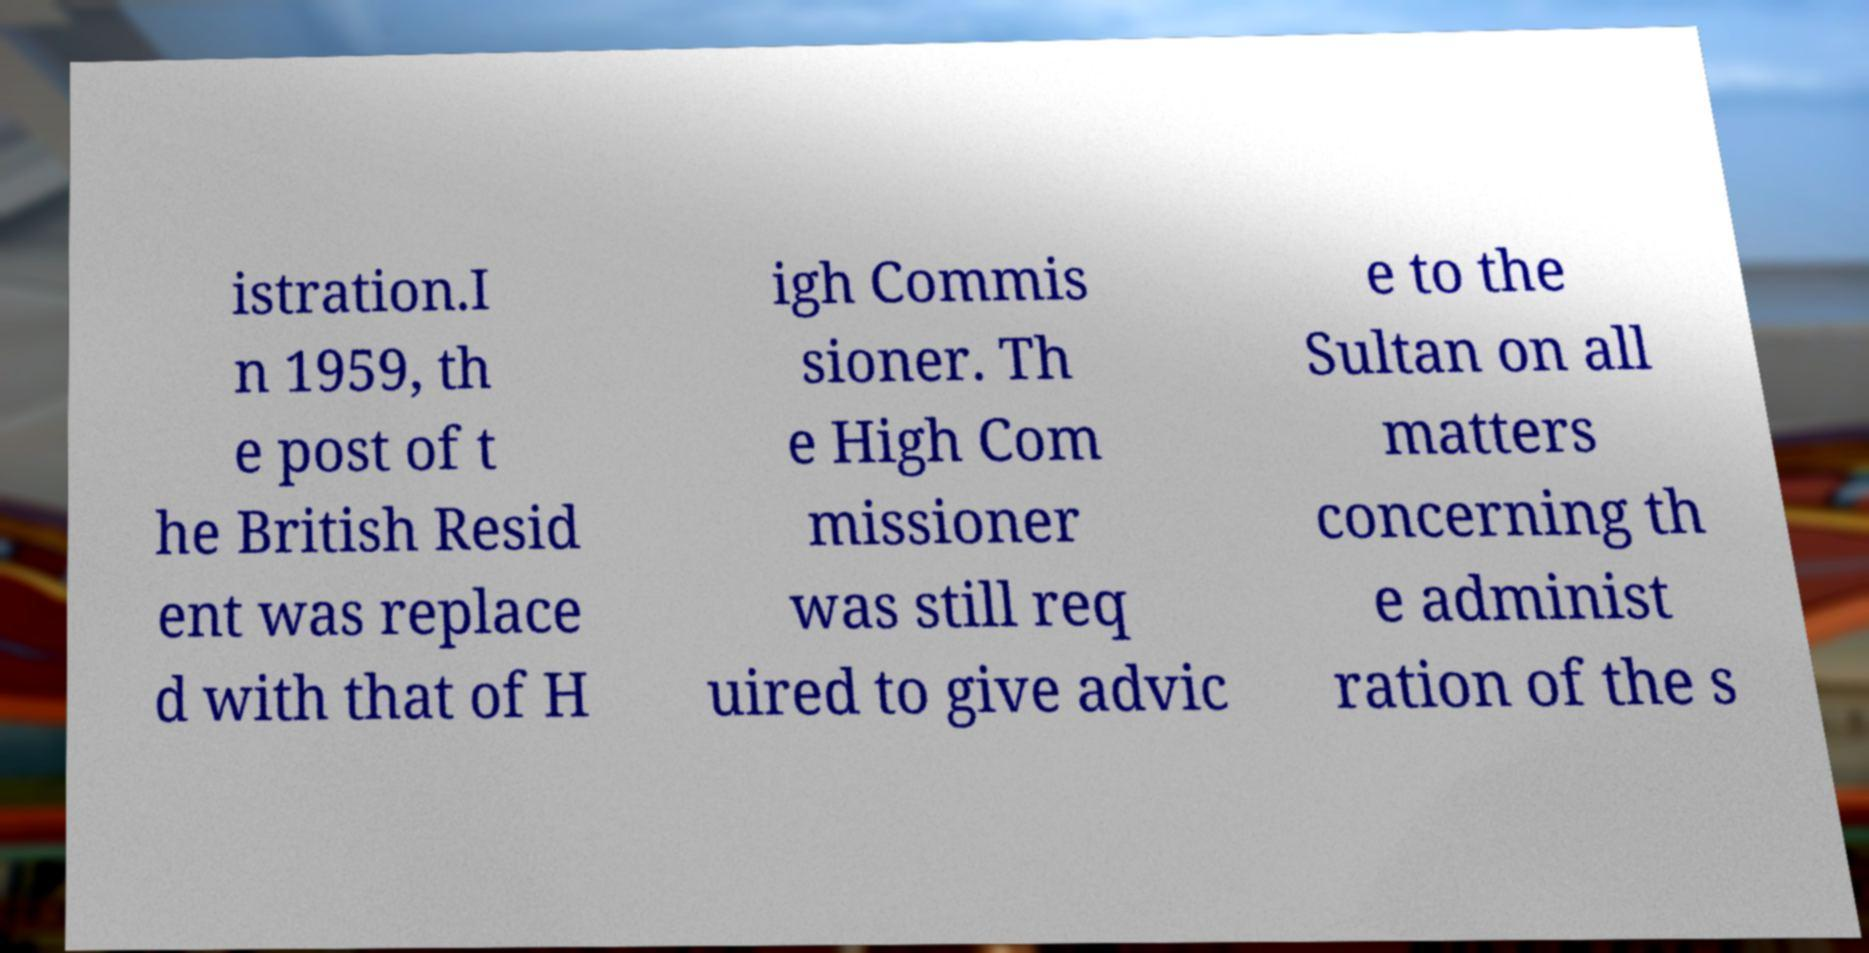Please read and relay the text visible in this image. What does it say? istration.I n 1959, th e post of t he British Resid ent was replace d with that of H igh Commis sioner. Th e High Com missioner was still req uired to give advic e to the Sultan on all matters concerning th e administ ration of the s 